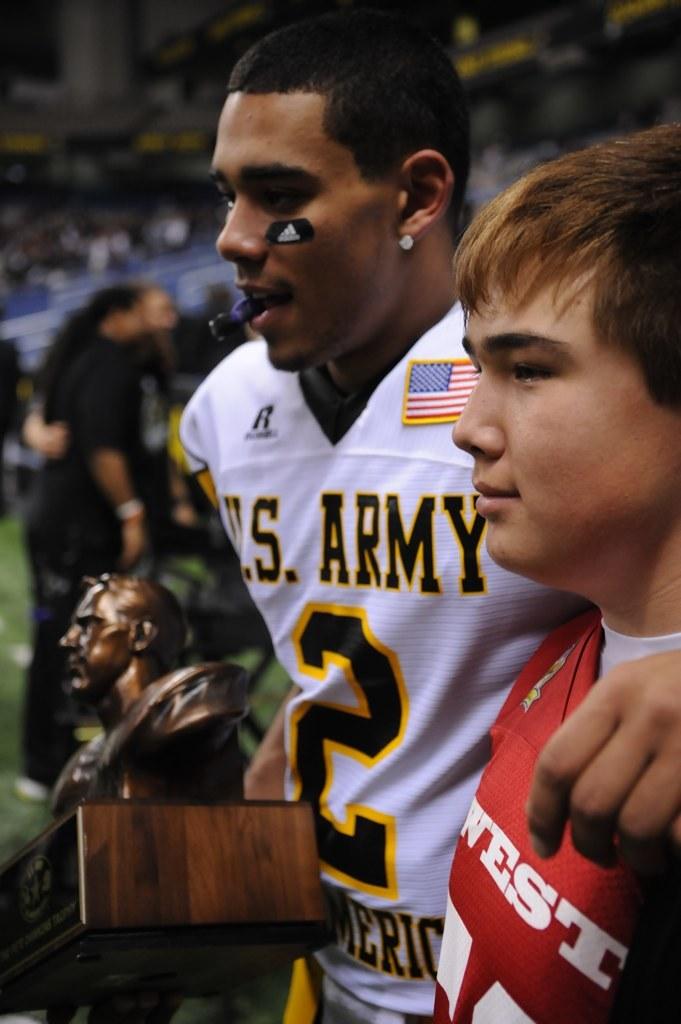Is that player 2?
Provide a short and direct response. Yes. What team does player 2 play for?
Provide a succinct answer. U.s. army. 